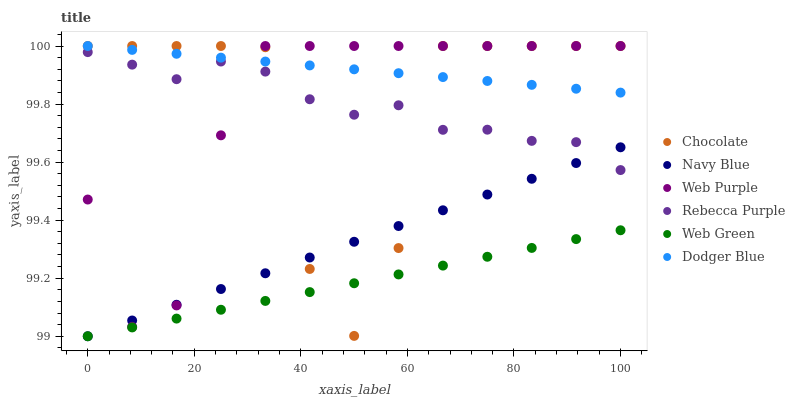Does Web Green have the minimum area under the curve?
Answer yes or no. Yes. Does Dodger Blue have the maximum area under the curve?
Answer yes or no. Yes. Does Chocolate have the minimum area under the curve?
Answer yes or no. No. Does Chocolate have the maximum area under the curve?
Answer yes or no. No. Is Navy Blue the smoothest?
Answer yes or no. Yes. Is Chocolate the roughest?
Answer yes or no. Yes. Is Web Green the smoothest?
Answer yes or no. No. Is Web Green the roughest?
Answer yes or no. No. Does Navy Blue have the lowest value?
Answer yes or no. Yes. Does Chocolate have the lowest value?
Answer yes or no. No. Does Dodger Blue have the highest value?
Answer yes or no. Yes. Does Web Green have the highest value?
Answer yes or no. No. Is Web Green less than Dodger Blue?
Answer yes or no. Yes. Is Dodger Blue greater than Navy Blue?
Answer yes or no. Yes. Does Web Purple intersect Rebecca Purple?
Answer yes or no. Yes. Is Web Purple less than Rebecca Purple?
Answer yes or no. No. Is Web Purple greater than Rebecca Purple?
Answer yes or no. No. Does Web Green intersect Dodger Blue?
Answer yes or no. No. 